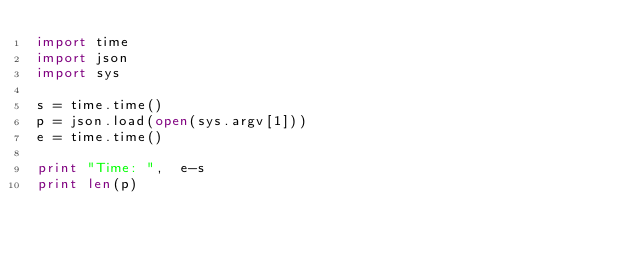Convert code to text. <code><loc_0><loc_0><loc_500><loc_500><_Python_>import time
import json
import sys

s = time.time()
p = json.load(open(sys.argv[1]))
e = time.time()

print "Time: ",  e-s
print len(p)
</code> 